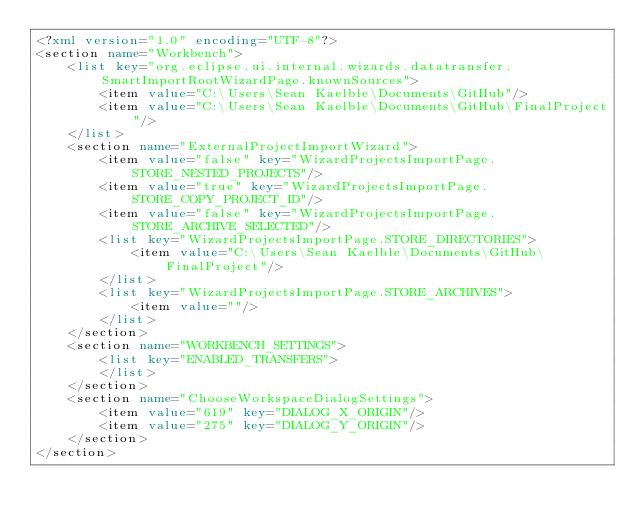<code> <loc_0><loc_0><loc_500><loc_500><_XML_><?xml version="1.0" encoding="UTF-8"?>
<section name="Workbench">
	<list key="org.eclipse.ui.internal.wizards.datatransfer.SmartImportRootWizardPage.knownSources">
		<item value="C:\Users\Sean Kaelble\Documents\GitHub"/>
		<item value="C:\Users\Sean Kaelble\Documents\GitHub\FinalProject"/>
	</list>
	<section name="ExternalProjectImportWizard">
		<item value="false" key="WizardProjectsImportPage.STORE_NESTED_PROJECTS"/>
		<item value="true" key="WizardProjectsImportPage.STORE_COPY_PROJECT_ID"/>
		<item value="false" key="WizardProjectsImportPage.STORE_ARCHIVE_SELECTED"/>
		<list key="WizardProjectsImportPage.STORE_DIRECTORIES">
			<item value="C:\Users\Sean Kaelble\Documents\GitHub\FinalProject"/>
		</list>
		<list key="WizardProjectsImportPage.STORE_ARCHIVES">
			<item value=""/>
		</list>
	</section>
	<section name="WORKBENCH_SETTINGS">
		<list key="ENABLED_TRANSFERS">
		</list>
	</section>
	<section name="ChooseWorkspaceDialogSettings">
		<item value="619" key="DIALOG_X_ORIGIN"/>
		<item value="275" key="DIALOG_Y_ORIGIN"/>
	</section>
</section>
</code> 